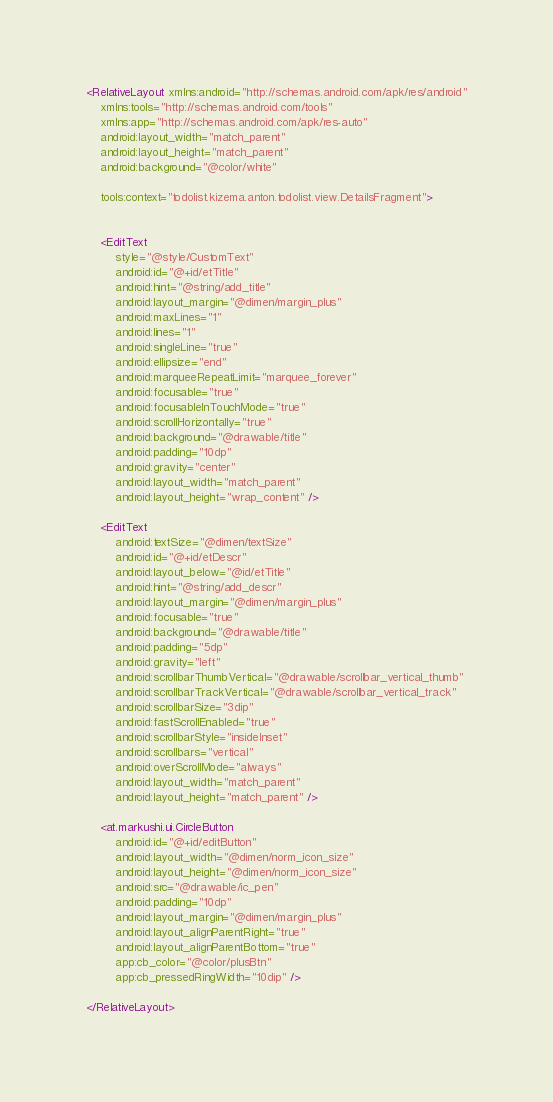Convert code to text. <code><loc_0><loc_0><loc_500><loc_500><_XML_><RelativeLayout xmlns:android="http://schemas.android.com/apk/res/android"
    xmlns:tools="http://schemas.android.com/tools"
    xmlns:app="http://schemas.android.com/apk/res-auto"
    android:layout_width="match_parent"
    android:layout_height="match_parent"
    android:background="@color/white"

    tools:context="todolist.kizema.anton.todolist.view.DetailsFragment">


    <EditText
        style="@style/CustomText"
        android:id="@+id/etTitle"
        android:hint="@string/add_title"
        android:layout_margin="@dimen/margin_plus"
        android:maxLines="1"
        android:lines="1"
        android:singleLine="true"
        android:ellipsize="end"
        android:marqueeRepeatLimit="marquee_forever"
        android:focusable="true"
        android:focusableInTouchMode="true"
        android:scrollHorizontally="true"
        android:background="@drawable/title"
        android:padding="10dp"
        android:gravity="center"
        android:layout_width="match_parent"
        android:layout_height="wrap_content" />

    <EditText
        android:textSize="@dimen/textSize"
        android:id="@+id/etDescr"
        android:layout_below="@id/etTitle"
        android:hint="@string/add_descr"
        android:layout_margin="@dimen/margin_plus"
        android:focusable="true"
        android:background="@drawable/title"
        android:padding="5dp"
        android:gravity="left"
        android:scrollbarThumbVertical="@drawable/scrollbar_vertical_thumb"
        android:scrollbarTrackVertical="@drawable/scrollbar_vertical_track"
        android:scrollbarSize="3dip"
        android:fastScrollEnabled="true"
        android:scrollbarStyle="insideInset"
        android:scrollbars="vertical"
        android:overScrollMode="always"
        android:layout_width="match_parent"
        android:layout_height="match_parent" />

    <at.markushi.ui.CircleButton
        android:id="@+id/editButton"
        android:layout_width="@dimen/norm_icon_size"
        android:layout_height="@dimen/norm_icon_size"
        android:src="@drawable/ic_pen"
        android:padding="10dp"
        android:layout_margin="@dimen/margin_plus"
        android:layout_alignParentRight="true"
        android:layout_alignParentBottom="true"
        app:cb_color="@color/plusBtn"
        app:cb_pressedRingWidth="10dip" />

</RelativeLayout>
</code> 